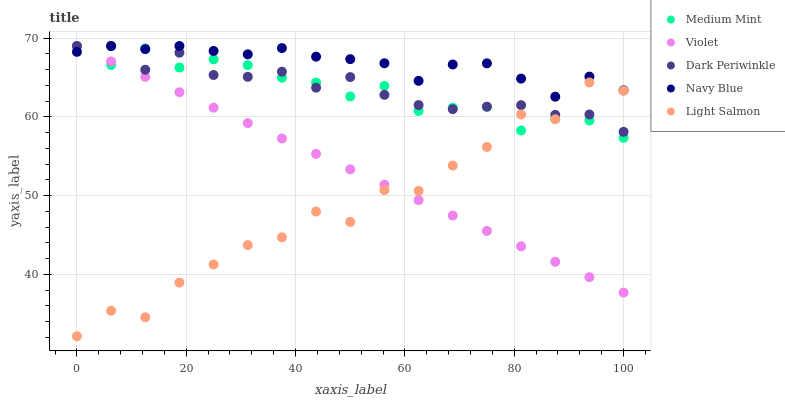Does Light Salmon have the minimum area under the curve?
Answer yes or no. Yes. Does Navy Blue have the maximum area under the curve?
Answer yes or no. Yes. Does Navy Blue have the minimum area under the curve?
Answer yes or no. No. Does Light Salmon have the maximum area under the curve?
Answer yes or no. No. Is Violet the smoothest?
Answer yes or no. Yes. Is Light Salmon the roughest?
Answer yes or no. Yes. Is Navy Blue the smoothest?
Answer yes or no. No. Is Navy Blue the roughest?
Answer yes or no. No. Does Light Salmon have the lowest value?
Answer yes or no. Yes. Does Navy Blue have the lowest value?
Answer yes or no. No. Does Violet have the highest value?
Answer yes or no. Yes. Does Light Salmon have the highest value?
Answer yes or no. No. Is Light Salmon less than Navy Blue?
Answer yes or no. Yes. Is Navy Blue greater than Light Salmon?
Answer yes or no. Yes. Does Medium Mint intersect Navy Blue?
Answer yes or no. Yes. Is Medium Mint less than Navy Blue?
Answer yes or no. No. Is Medium Mint greater than Navy Blue?
Answer yes or no. No. Does Light Salmon intersect Navy Blue?
Answer yes or no. No. 